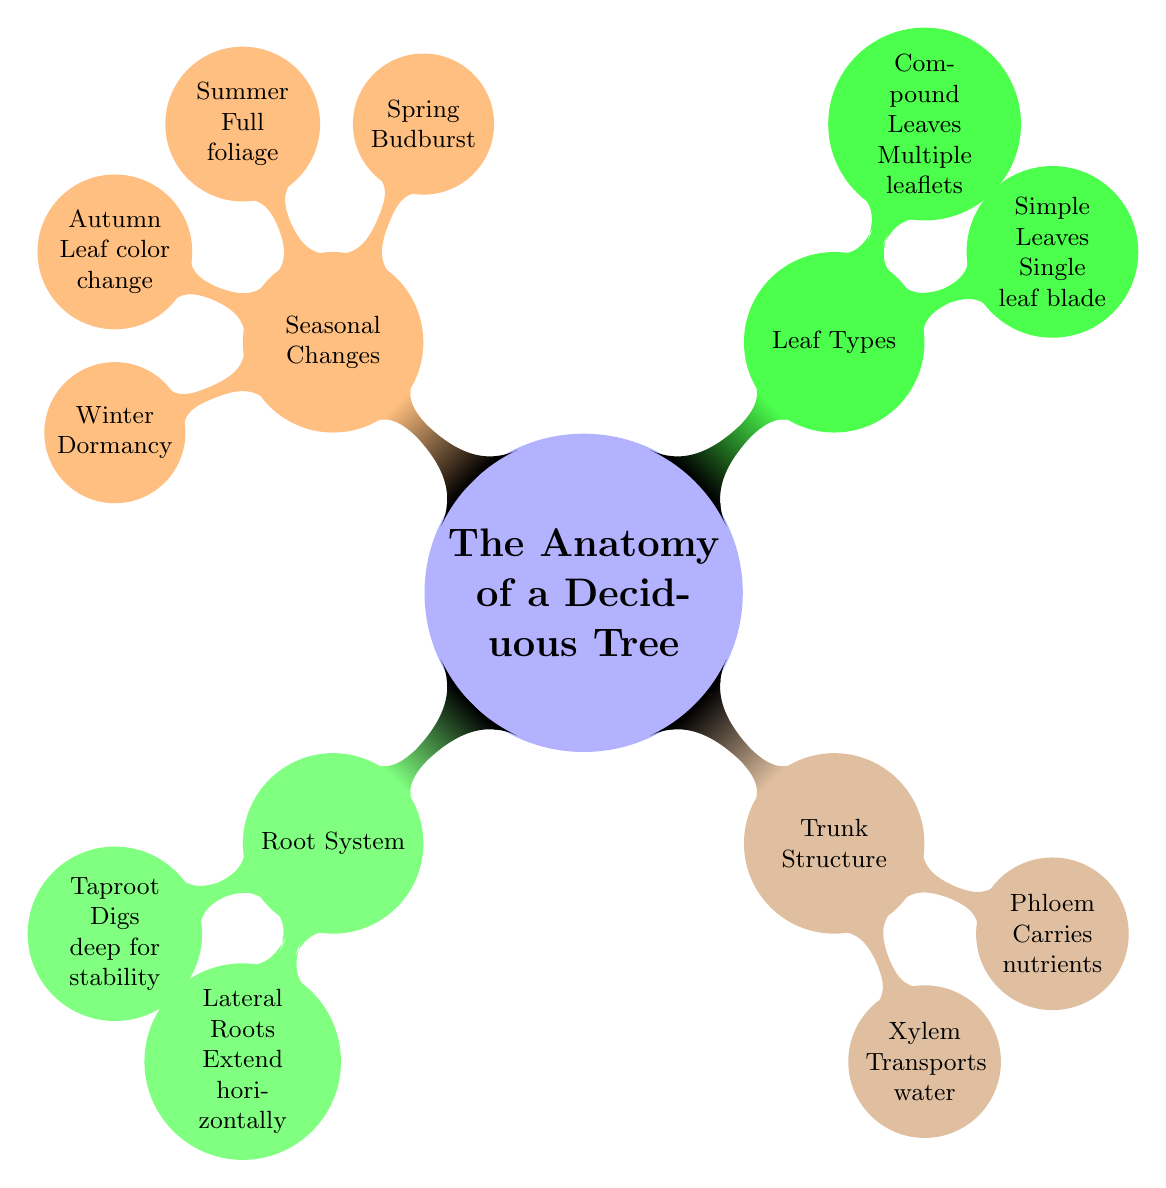What are the two types of roots in the root system? The diagram indicates two specific types of roots under the root system: "Taproot" and "Lateral Roots." These can be identified directly as they are labeled underneath the root system node.
Answer: Taproot, Lateral Roots What does the xylem transport? According to the trunk structure section of the diagram, the xylem is explicitly stated to transport water. This information is found directly under the xylem label.
Answer: Water How many types of leaf types are shown in the diagram? In the leaf types section, there are two specified types: "Simple Leaves" and "Compound Leaves." Counting these gives a total of two leaf types represented.
Answer: 2 What seasonal change occurs in spring? The diagram indicates that the seasonal change occurring in spring is "Budburst." This is labeled under the seasonal changes section specifically for spring.
Answer: Budburst What is the relationship between phloem and nutrients? The diagram shows that phloem "Carries nutrients," establishing a direct relationship whereby phloem is responsible for the transportation of nutrients within the tree structure.
Answer: Carries nutrients Which season is characterized by dormancy? The seasonal changes section of the diagram indicates that "Winter" is the season characterized by dormancy. This is listed explicitly alongside other seasonal changes.
Answer: Winter How do simple leaves differ from compound leaves? The diagram illustrates that simple leaves have "Single leaf blade," while compound leaves consist of "Multiple leaflets." This comparison highlights how they differ in structure.
Answer: Single leaf blade, Multiple leaflets What color change occurs in autumn? In the diagram, autumn is noted for "Leaf color change," which directly indicates the specific change that happens during this season.
Answer: Leaf color change What is the purpose of the taproot? The diagram states that the taproot "Digs deep for stability," which explains its function within the root system as it helps stabilize the tree.
Answer: Digs deep for stability 